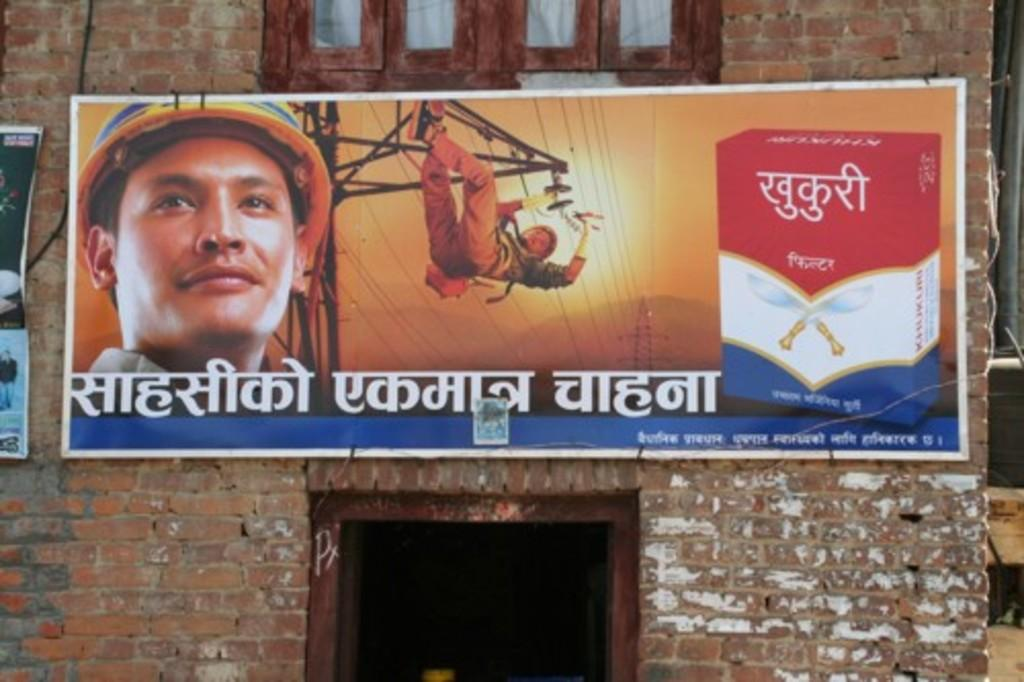What is attached to the wall in the image? There is a poster attached to the wall in the image. What architectural feature can be used to enter or exit a room in the image? There is a door in the image. What allows natural light to enter the room in the image? There is a window in the image. What can be seen on the right side of the image? There appears to be a rod on the right side of the image. Can you see any cats playing with the lock on the door in the image? There are no cats or locks present in the image. How many bears are visible in the window in the image? There are no bears visible in the image; only a window is present. 